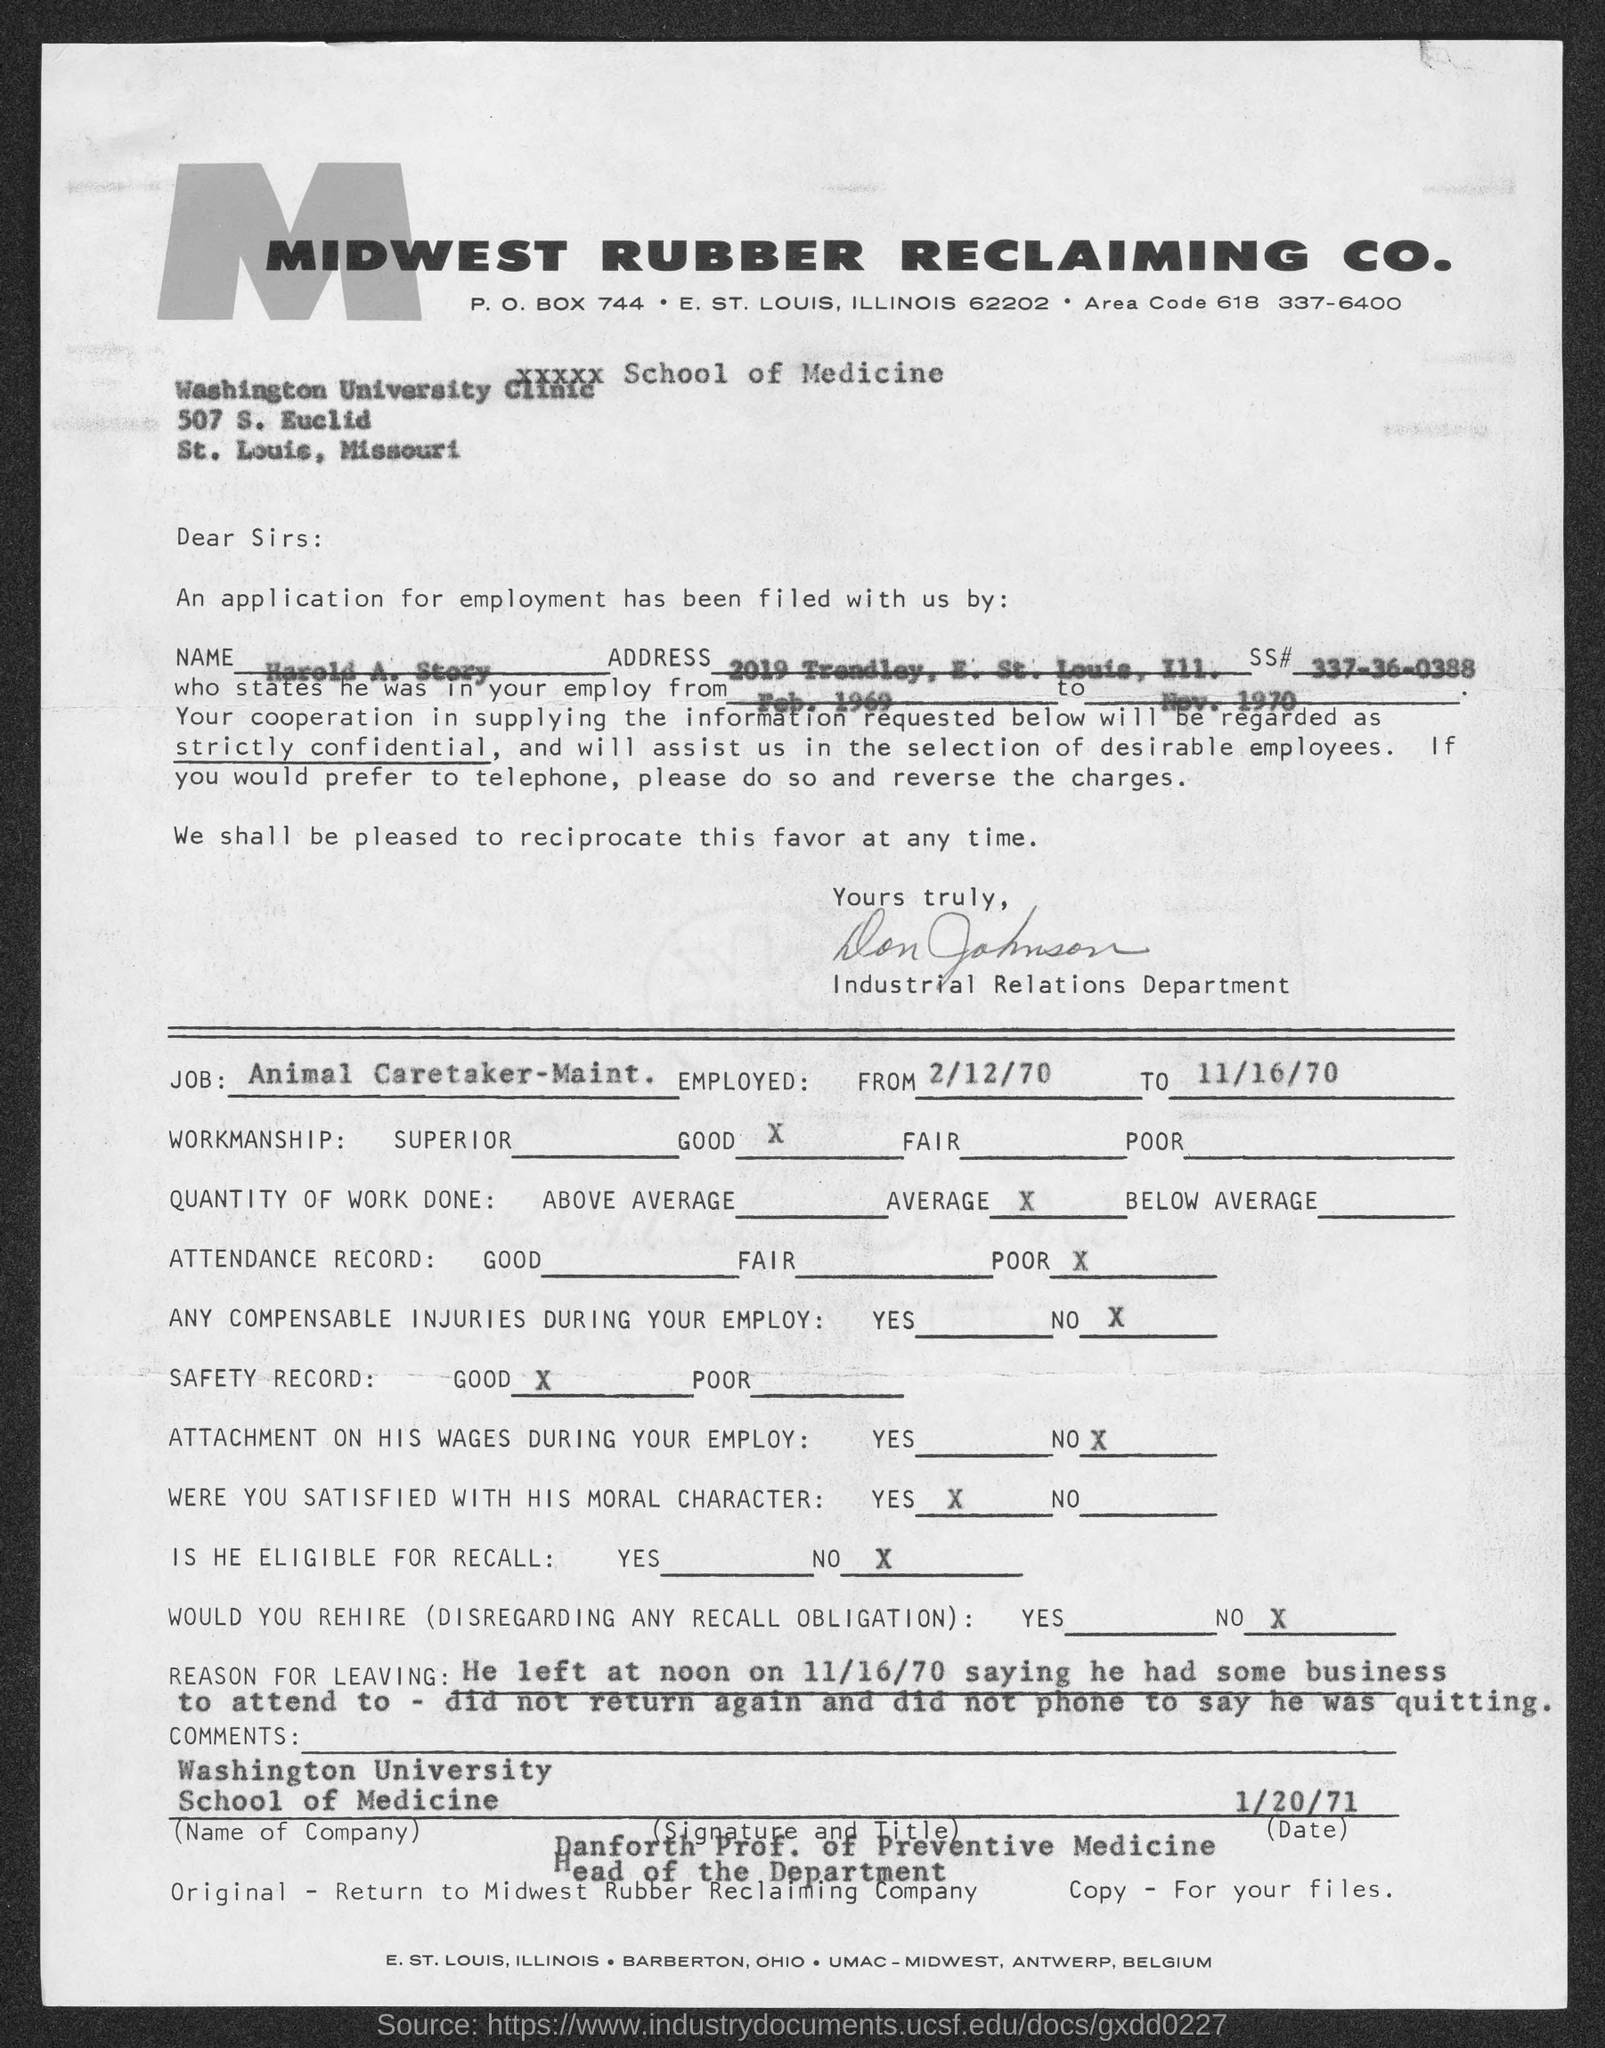What is the area code?
Your answer should be compact. 618. What is the p.o. box no. of midwest rubber reclaiming co.?
Provide a succinct answer. 744. What is the name of the applicant?
Your answer should be compact. Harold A. story. What is the ss# of the applicant ?
Your answer should be very brief. 337-36-0388. 